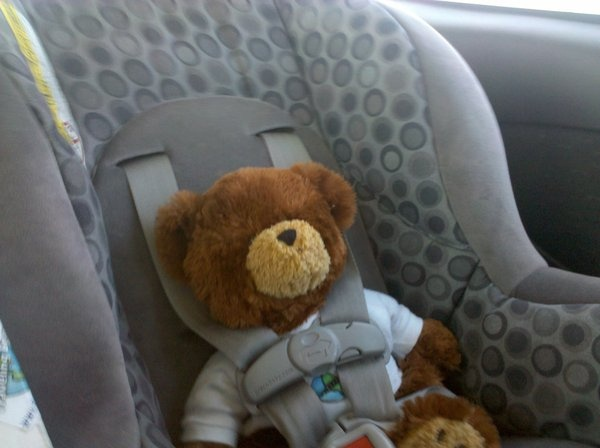Describe the objects in this image and their specific colors. I can see chair in tan, gray, black, and darkgray tones and teddy bear in tan, maroon, black, and gray tones in this image. 